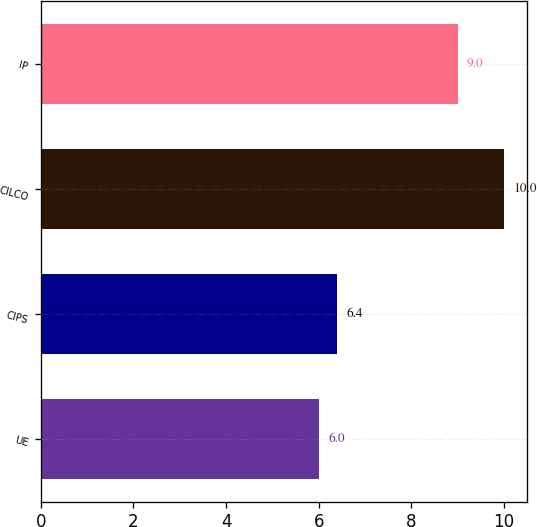Convert chart. <chart><loc_0><loc_0><loc_500><loc_500><bar_chart><fcel>UE<fcel>CIPS<fcel>CILCO<fcel>IP<nl><fcel>6<fcel>6.4<fcel>10<fcel>9<nl></chart> 